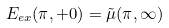Convert formula to latex. <formula><loc_0><loc_0><loc_500><loc_500>E _ { e x } ( \pi , + 0 ) = { \tilde { \mu } } ( \pi , \infty )</formula> 